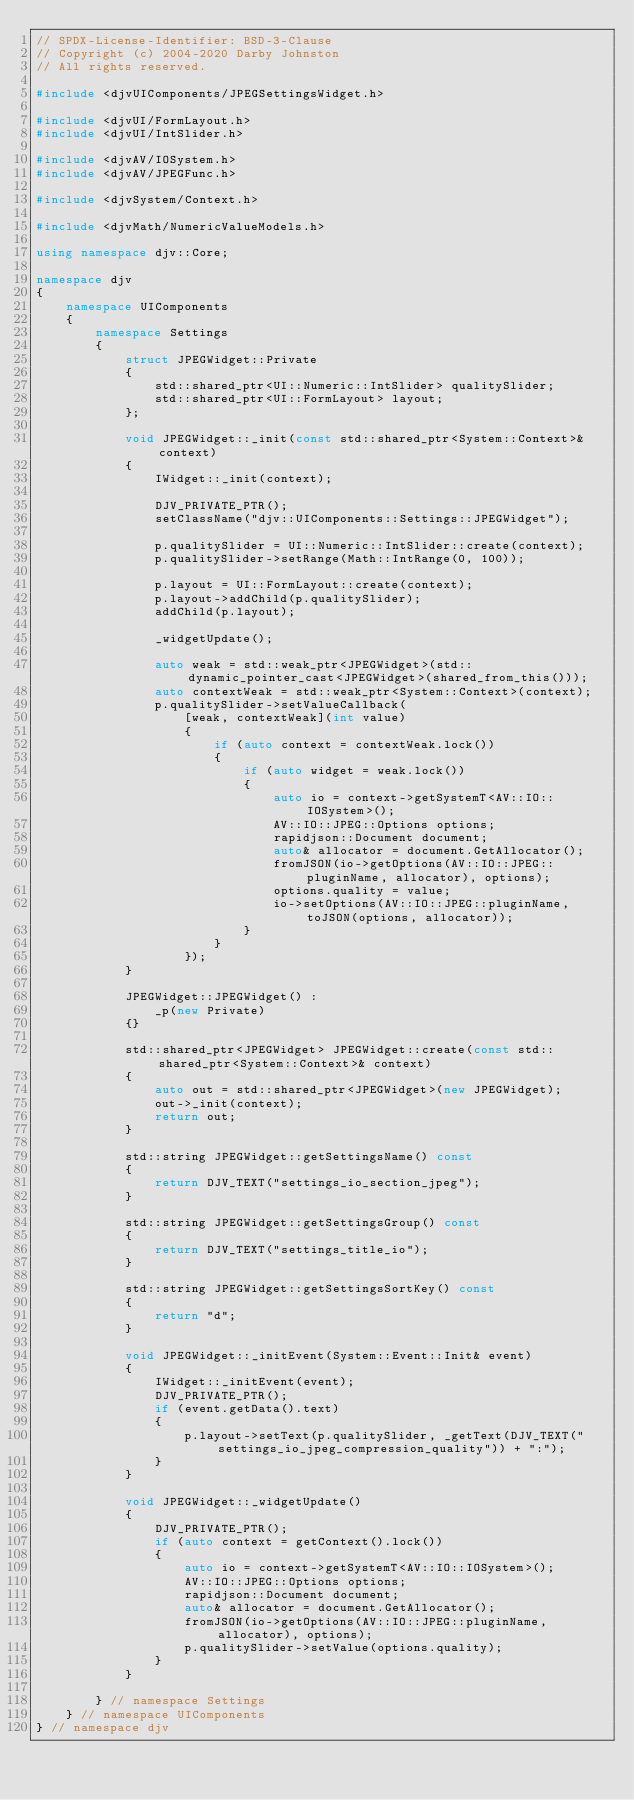Convert code to text. <code><loc_0><loc_0><loc_500><loc_500><_C++_>// SPDX-License-Identifier: BSD-3-Clause
// Copyright (c) 2004-2020 Darby Johnston
// All rights reserved.

#include <djvUIComponents/JPEGSettingsWidget.h>

#include <djvUI/FormLayout.h>
#include <djvUI/IntSlider.h>

#include <djvAV/IOSystem.h>
#include <djvAV/JPEGFunc.h>

#include <djvSystem/Context.h>

#include <djvMath/NumericValueModels.h>

using namespace djv::Core;

namespace djv
{
    namespace UIComponents
    {
        namespace Settings
        {
            struct JPEGWidget::Private
            {
                std::shared_ptr<UI::Numeric::IntSlider> qualitySlider;
                std::shared_ptr<UI::FormLayout> layout;
            };

            void JPEGWidget::_init(const std::shared_ptr<System::Context>& context)
            {
                IWidget::_init(context);

                DJV_PRIVATE_PTR();
                setClassName("djv::UIComponents::Settings::JPEGWidget");

                p.qualitySlider = UI::Numeric::IntSlider::create(context);
                p.qualitySlider->setRange(Math::IntRange(0, 100));

                p.layout = UI::FormLayout::create(context);
                p.layout->addChild(p.qualitySlider);
                addChild(p.layout);

                _widgetUpdate();

                auto weak = std::weak_ptr<JPEGWidget>(std::dynamic_pointer_cast<JPEGWidget>(shared_from_this()));
                auto contextWeak = std::weak_ptr<System::Context>(context);
                p.qualitySlider->setValueCallback(
                    [weak, contextWeak](int value)
                    {
                        if (auto context = contextWeak.lock())
                        {
                            if (auto widget = weak.lock())
                            {
                                auto io = context->getSystemT<AV::IO::IOSystem>();
                                AV::IO::JPEG::Options options;
                                rapidjson::Document document;
                                auto& allocator = document.GetAllocator();
                                fromJSON(io->getOptions(AV::IO::JPEG::pluginName, allocator), options);
                                options.quality = value;
                                io->setOptions(AV::IO::JPEG::pluginName, toJSON(options, allocator));
                            }
                        }
                    });
            }

            JPEGWidget::JPEGWidget() :
                _p(new Private)
            {}

            std::shared_ptr<JPEGWidget> JPEGWidget::create(const std::shared_ptr<System::Context>& context)
            {
                auto out = std::shared_ptr<JPEGWidget>(new JPEGWidget);
                out->_init(context);
                return out;
            }

            std::string JPEGWidget::getSettingsName() const
            {
                return DJV_TEXT("settings_io_section_jpeg");
            }

            std::string JPEGWidget::getSettingsGroup() const
            {
                return DJV_TEXT("settings_title_io");
            }

            std::string JPEGWidget::getSettingsSortKey() const
            {
                return "d";
            }

            void JPEGWidget::_initEvent(System::Event::Init& event)
            {
                IWidget::_initEvent(event);
                DJV_PRIVATE_PTR();
                if (event.getData().text)
                {
                    p.layout->setText(p.qualitySlider, _getText(DJV_TEXT("settings_io_jpeg_compression_quality")) + ":");
                }
            }

            void JPEGWidget::_widgetUpdate()
            {
                DJV_PRIVATE_PTR();
                if (auto context = getContext().lock())
                {
                    auto io = context->getSystemT<AV::IO::IOSystem>();
                    AV::IO::JPEG::Options options;
                    rapidjson::Document document;
                    auto& allocator = document.GetAllocator();
                    fromJSON(io->getOptions(AV::IO::JPEG::pluginName, allocator), options);
                    p.qualitySlider->setValue(options.quality);
                }
            }

        } // namespace Settings
    } // namespace UIComponents
} // namespace djv

</code> 